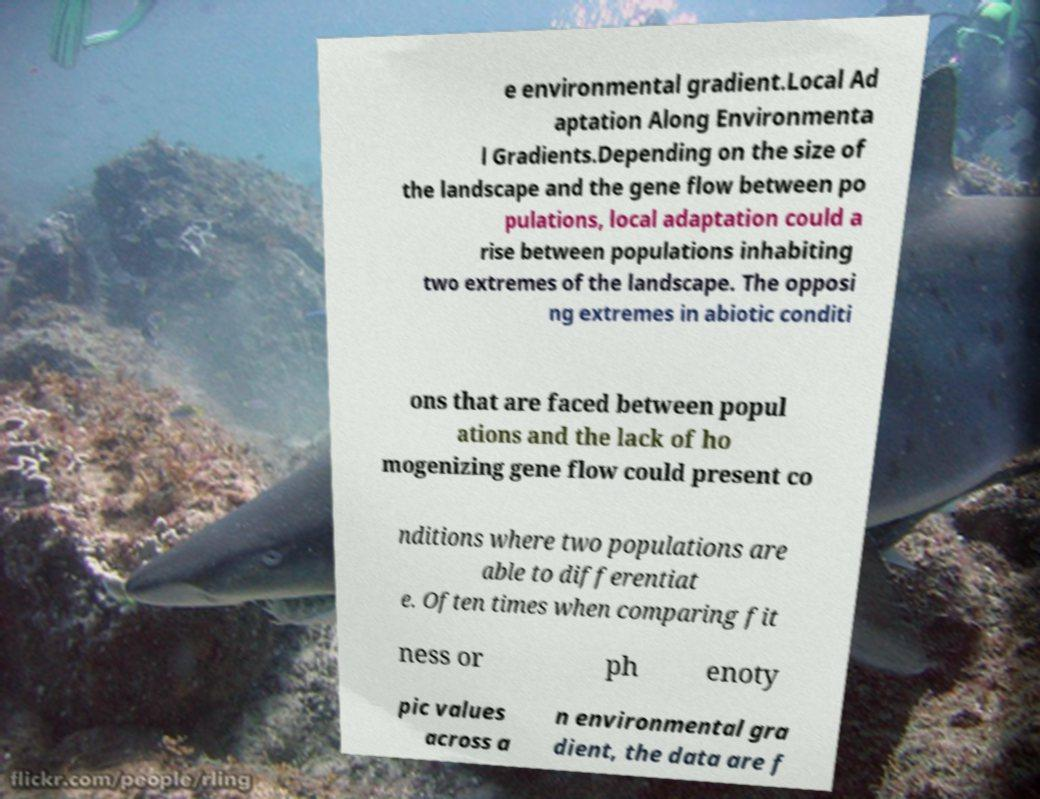Can you read and provide the text displayed in the image?This photo seems to have some interesting text. Can you extract and type it out for me? e environmental gradient.Local Ad aptation Along Environmenta l Gradients.Depending on the size of the landscape and the gene flow between po pulations, local adaptation could a rise between populations inhabiting two extremes of the landscape. The opposi ng extremes in abiotic conditi ons that are faced between popul ations and the lack of ho mogenizing gene flow could present co nditions where two populations are able to differentiat e. Often times when comparing fit ness or ph enoty pic values across a n environmental gra dient, the data are f 